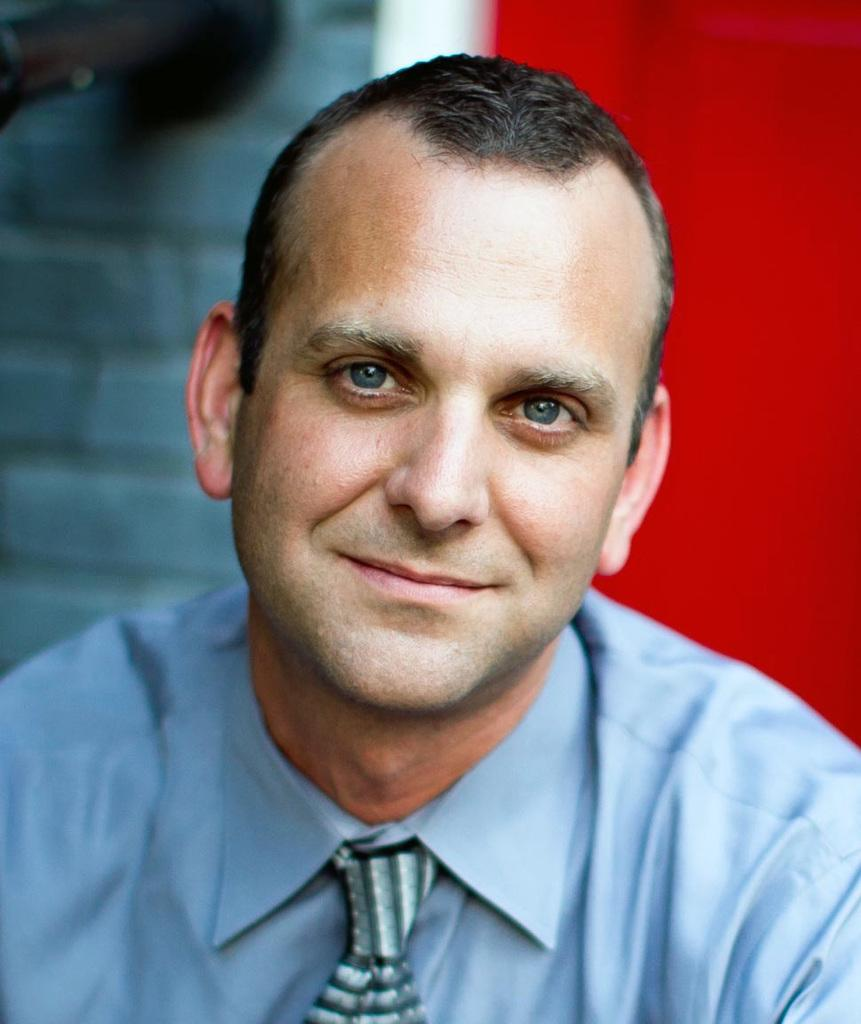What is the main subject of the image? There is a person in the image. Can you describe the background of the image? The background of the image is blurred. What can be observed about the person's attire in the image? The person in the image is wearing clothes. How many legs does the toad have in the image? There is no toad present in the image. 